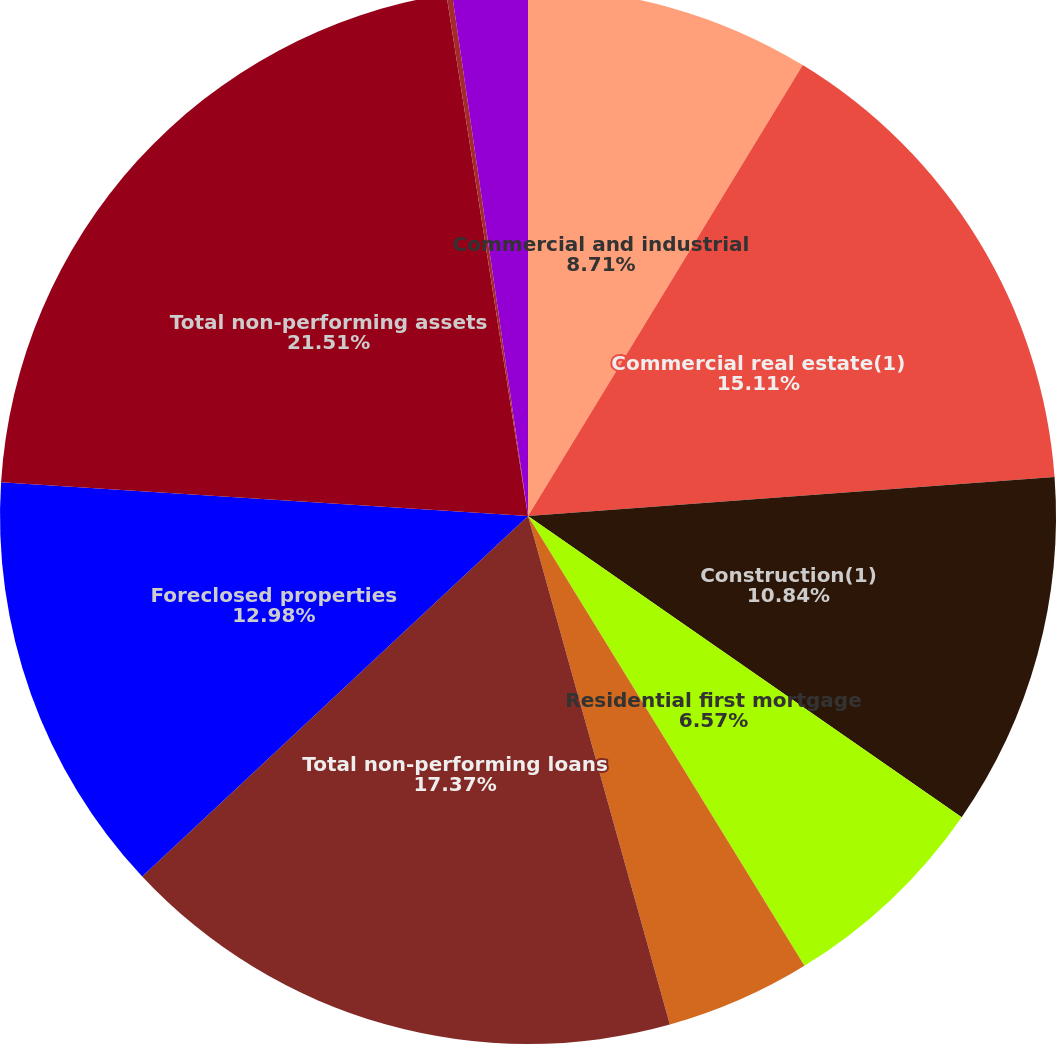<chart> <loc_0><loc_0><loc_500><loc_500><pie_chart><fcel>Commercial and industrial<fcel>Commercial real estate(1)<fcel>Construction(1)<fcel>Residential first mortgage<fcel>Home equity<fcel>Total non-performing loans<fcel>Foreclosed properties<fcel>Total non-performing assets<fcel>Indirect<fcel>Other consumer<nl><fcel>8.71%<fcel>15.11%<fcel>10.84%<fcel>6.57%<fcel>4.44%<fcel>17.37%<fcel>12.98%<fcel>21.51%<fcel>0.17%<fcel>2.3%<nl></chart> 